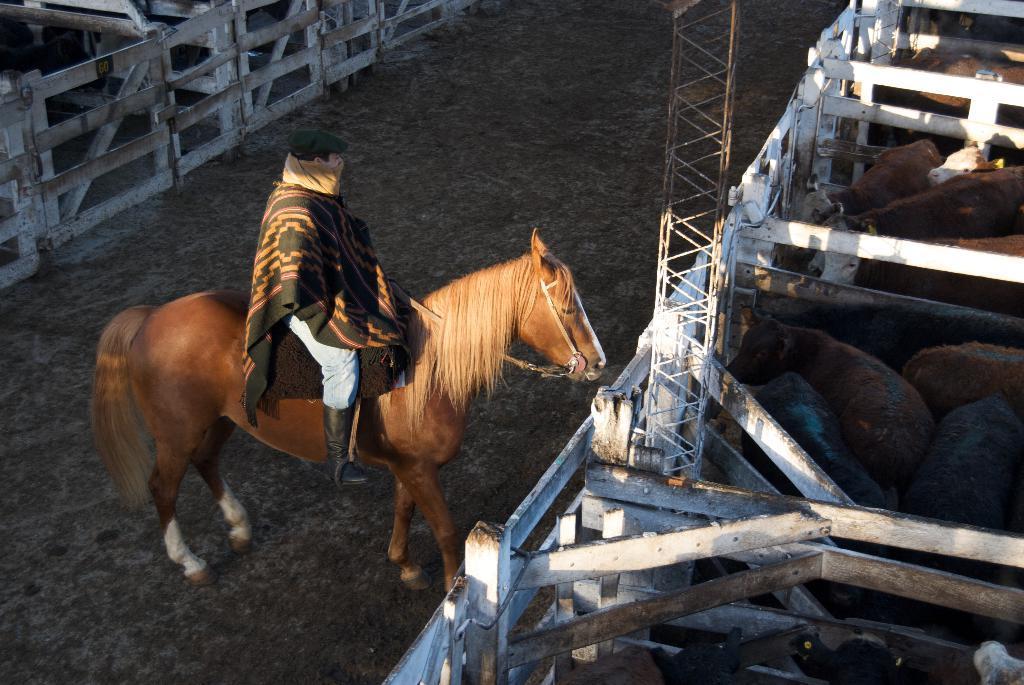How would you summarize this image in a sentence or two? In this image the person is sitting on the horse and there are some cows. 